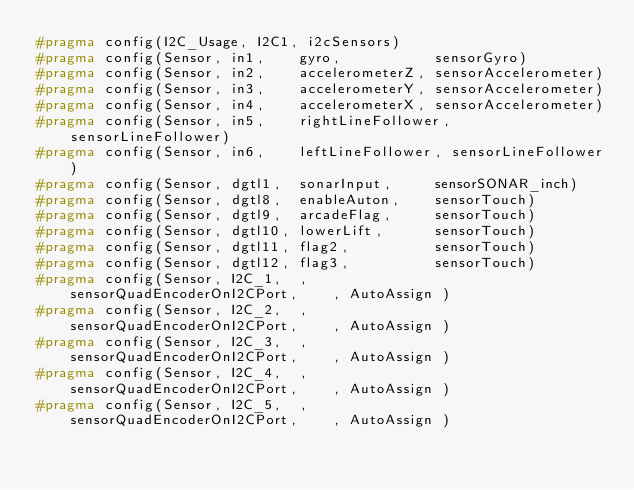Convert code to text. <code><loc_0><loc_0><loc_500><loc_500><_C_>#pragma config(I2C_Usage, I2C1, i2cSensors)
#pragma config(Sensor, in1,    gyro,           sensorGyro)
#pragma config(Sensor, in2,    accelerometerZ, sensorAccelerometer)
#pragma config(Sensor, in3,    accelerometerY, sensorAccelerometer)
#pragma config(Sensor, in4,    accelerometerX, sensorAccelerometer)
#pragma config(Sensor, in5,    rightLineFollower, sensorLineFollower)
#pragma config(Sensor, in6,    leftLineFollower, sensorLineFollower)
#pragma config(Sensor, dgtl1,  sonarInput,     sensorSONAR_inch)
#pragma config(Sensor, dgtl8,  enableAuton,    sensorTouch)
#pragma config(Sensor, dgtl9,  arcadeFlag,     sensorTouch)
#pragma config(Sensor, dgtl10, lowerLift,      sensorTouch)
#pragma config(Sensor, dgtl11, flag2,          sensorTouch)
#pragma config(Sensor, dgtl12, flag3,          sensorTouch)
#pragma config(Sensor, I2C_1,  ,               sensorQuadEncoderOnI2CPort,    , AutoAssign )
#pragma config(Sensor, I2C_2,  ,               sensorQuadEncoderOnI2CPort,    , AutoAssign )
#pragma config(Sensor, I2C_3,  ,               sensorQuadEncoderOnI2CPort,    , AutoAssign )
#pragma config(Sensor, I2C_4,  ,               sensorQuadEncoderOnI2CPort,    , AutoAssign )
#pragma config(Sensor, I2C_5,  ,               sensorQuadEncoderOnI2CPort,    , AutoAssign )</code> 